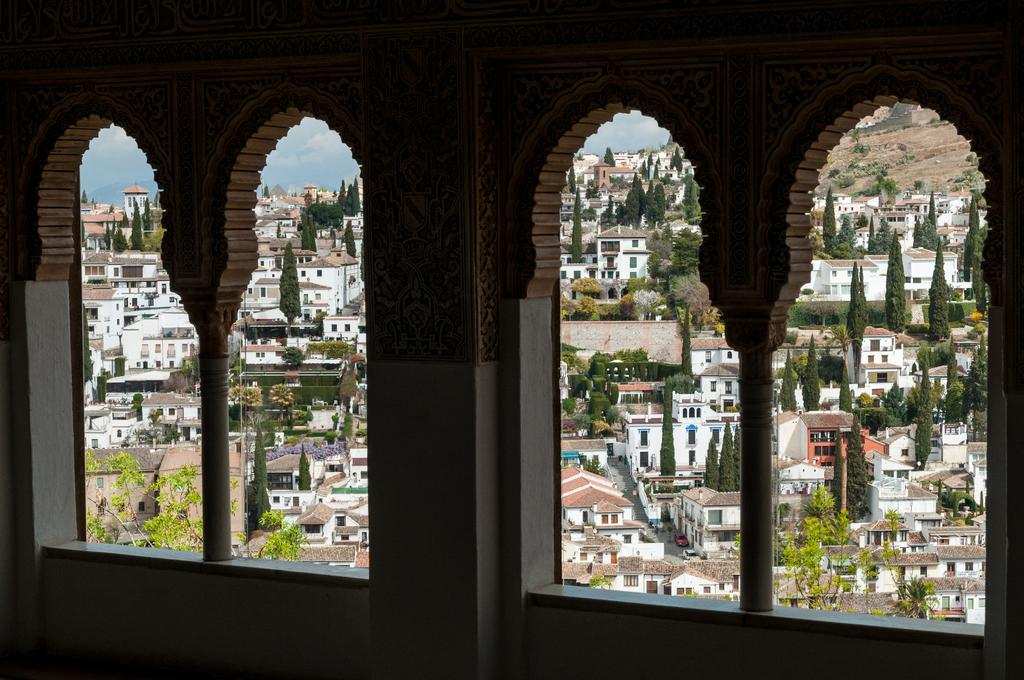What can be seen through the windows in the image? Buildings and trees are visible through the windows in the image. What else is present in front of the building? There are vehicles in front of the building. How is the wall designed? The wall is designed with a specific pattern or style. What is the school's current enrollment rate in the image? There is no information about a school or enrollment rate in the image. What surprise can be seen in the image? There is no surprise or unexpected element present in the image. 